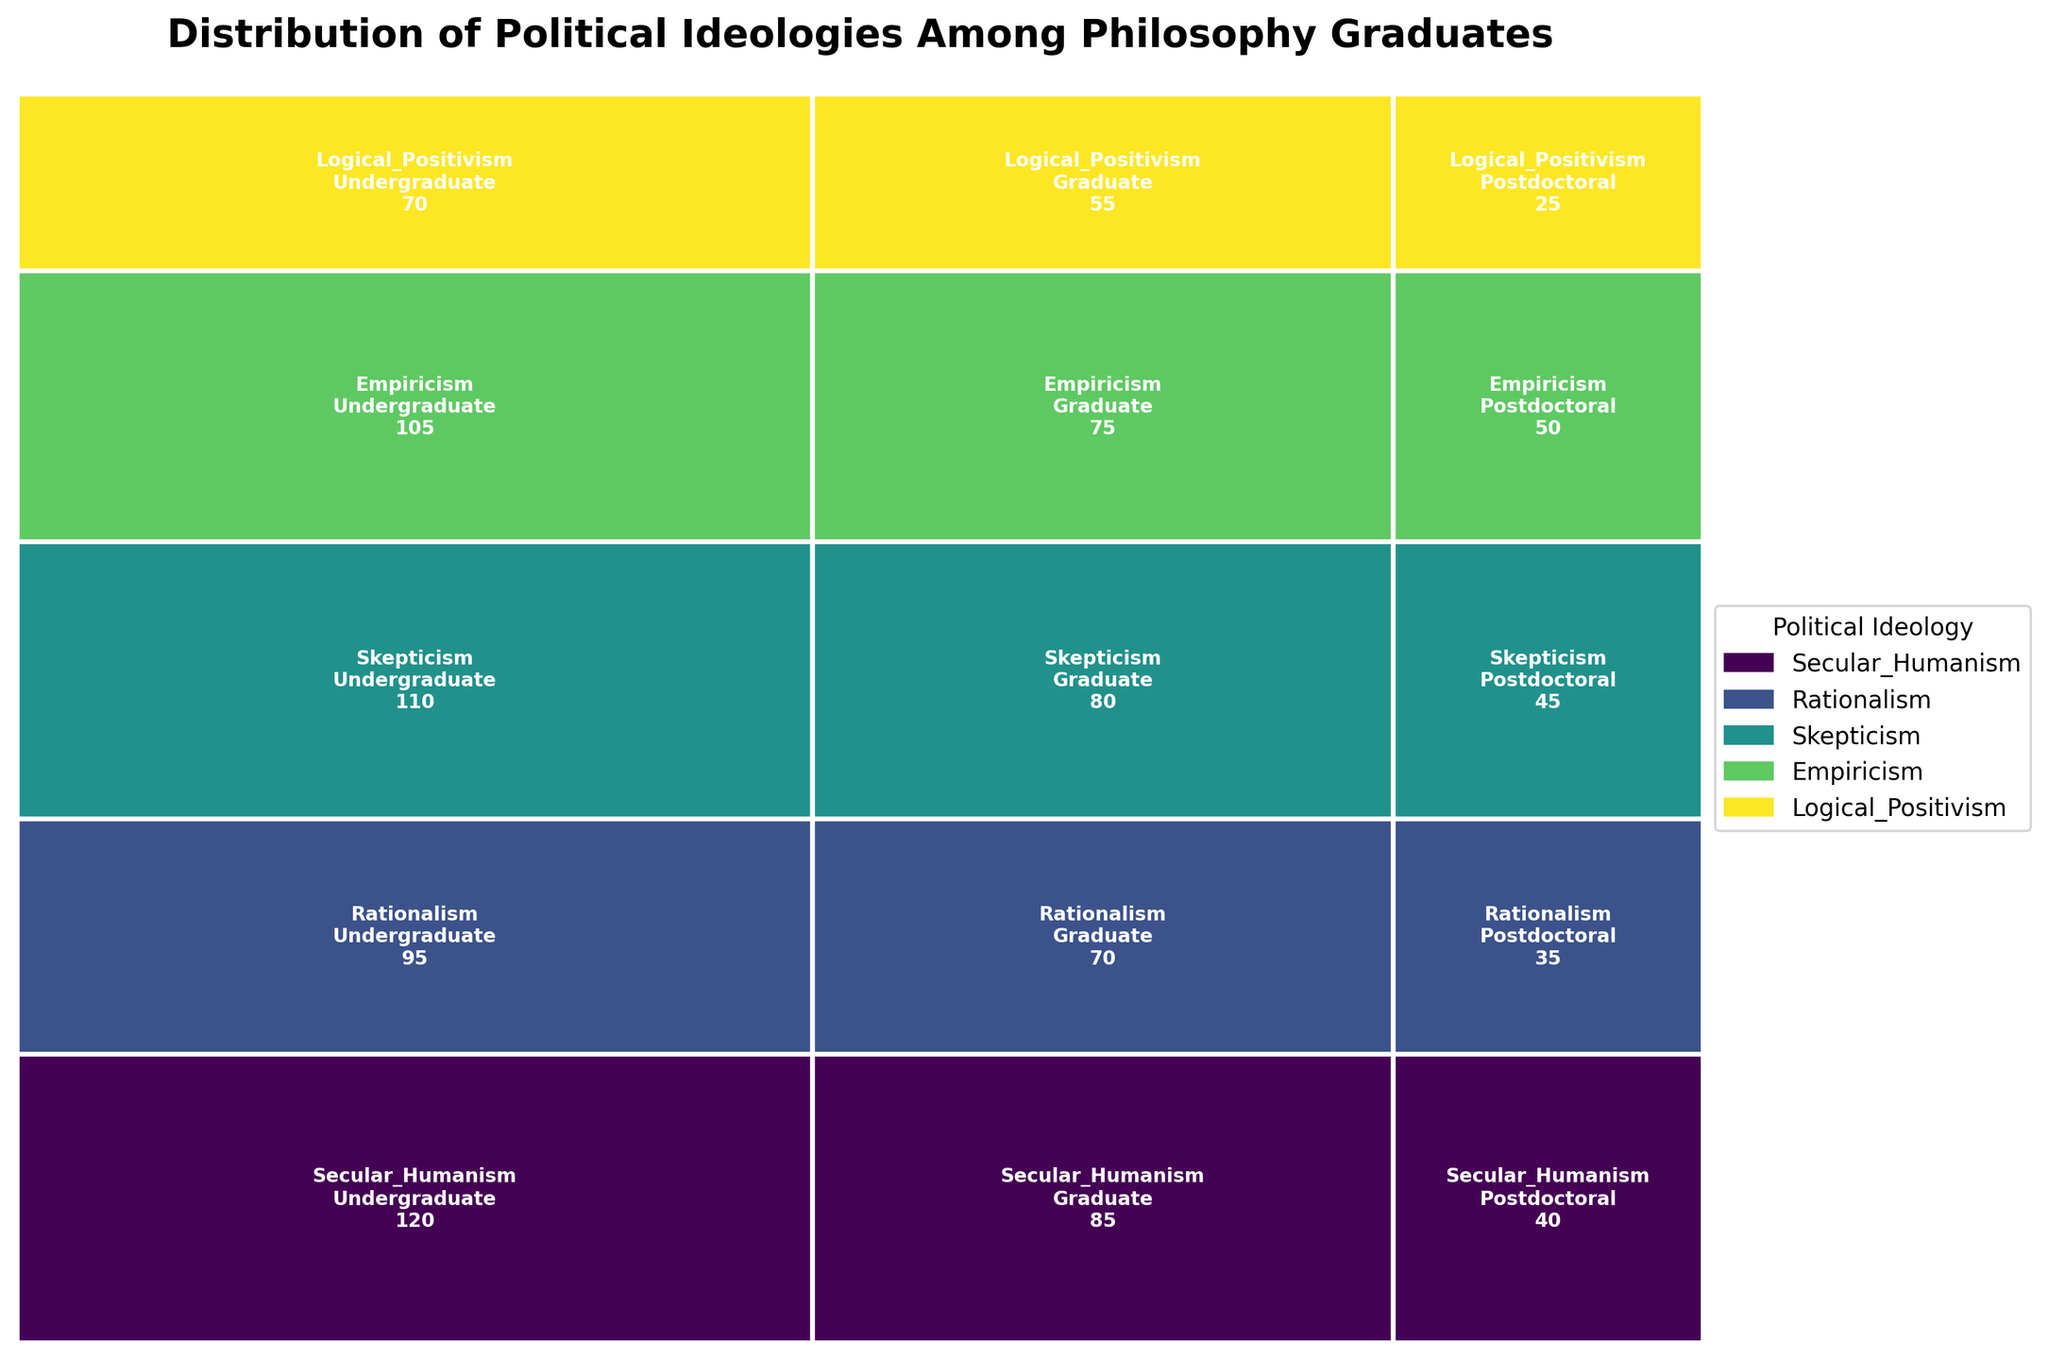What is the title of the figure? The title is usually located at the top of the figure, providing an immediate understanding of what the plot represents. By examining the top of the figure, the title, "Distribution of Political Ideologies Among Philosophy Graduates," can be seen.
Answer: Distribution of Political Ideologies Among Philosophy Graduates Which political ideology has the highest count in the Postdoctoral academic level? Find all the segments corresponding to the Postdoctoral level and identify the tallest rectangle, which represents the highest count. From the plot, Skepticism has the highest count among Postdoctoral graduates.
Answer: Skepticism Which political ideology has the smallest portion at the Undergraduate academic level? Look at all the rectangles corresponding to the Undergraduate level and identify the one with the smallest height. From the plot, Logical Positivism has the smallest portion at the Undergraduate level.
Answer: Logical Positivism What is the combined count of Secular Humanism and Rationalism in the Postdoctoral level? First, find the rectangles for Secular Humanism and Rationalism at the Postdoctoral level, noting their counts as 40 and 35 respectively. Sum these counts: 40 + 35 = 75.
Answer: 75 How does the representation of Empiricism at the Postdoctoral level compare with that of Logical Positivism at the same level? Compare the two relevant rectangles at the Postdoctoral level, noting that Empiricism has a count of 50 while Logical Positivism has a count of 25. Since 50 is greater than 25, Empiricism is represented more.
Answer: Empiricism has a higher count than Logical Positivism What is the difference in counts between Secular Humanism and Rationalism at the Graduate level? Identify the counts for Secular Humanism and Rationalism at the Graduate level, which are 85 and 70 respectively. Calculate the difference: 85 - 70 = 15.
Answer: 15 Which ideology has the most evenly distributed counts across all academic levels? Examine the height of the rectangles for each ideology across Undergrad, Graduate, and Postdoctoral levels, and compare the consistency. Empiricism appears to have relatively similar heights across all levels, indicating an even distribution.
Answer: Empiricism What is the total count of people affiliated with Logical Positivism across all academic levels? Sum the counts of Logical Positivism across Undergraduate (70), Graduate (55), and Postdoctoral (25) levels: 70 + 55 + 25 = 150.
Answer: 150 